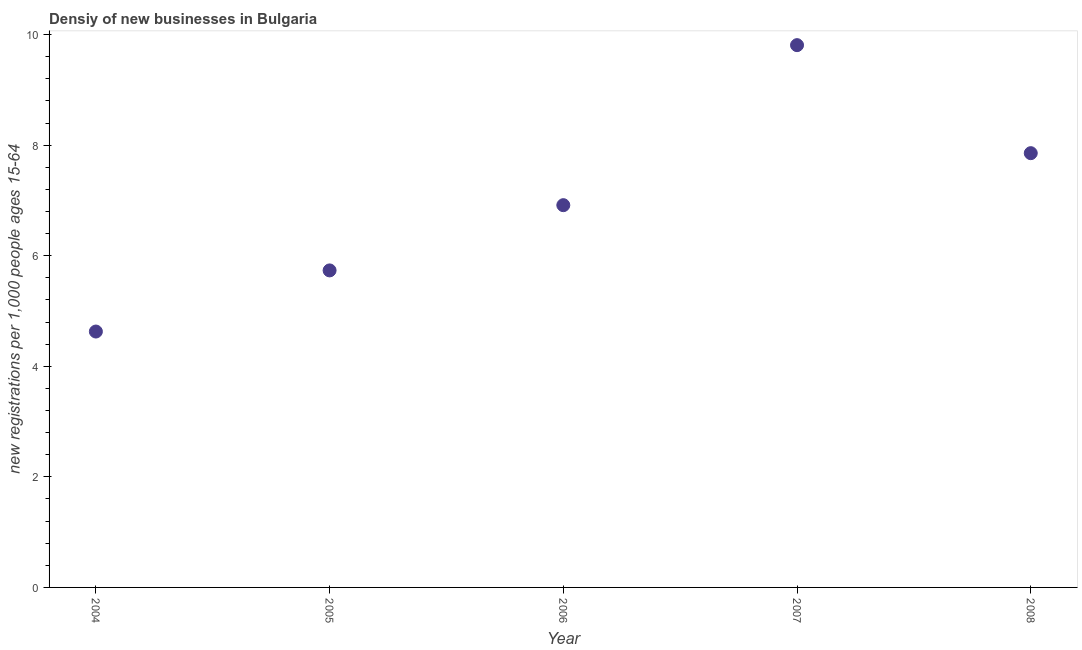What is the density of new business in 2004?
Your answer should be compact. 4.63. Across all years, what is the maximum density of new business?
Offer a terse response. 9.81. Across all years, what is the minimum density of new business?
Make the answer very short. 4.63. In which year was the density of new business minimum?
Offer a very short reply. 2004. What is the sum of the density of new business?
Your response must be concise. 34.94. What is the difference between the density of new business in 2005 and 2008?
Give a very brief answer. -2.12. What is the average density of new business per year?
Your response must be concise. 6.99. What is the median density of new business?
Your answer should be compact. 6.91. What is the ratio of the density of new business in 2004 to that in 2007?
Your answer should be compact. 0.47. Is the density of new business in 2005 less than that in 2007?
Provide a succinct answer. Yes. What is the difference between the highest and the second highest density of new business?
Offer a very short reply. 1.95. What is the difference between the highest and the lowest density of new business?
Your answer should be compact. 5.18. In how many years, is the density of new business greater than the average density of new business taken over all years?
Provide a short and direct response. 2. Does the density of new business monotonically increase over the years?
Your response must be concise. No. How many dotlines are there?
Your answer should be very brief. 1. What is the difference between two consecutive major ticks on the Y-axis?
Your answer should be compact. 2. Are the values on the major ticks of Y-axis written in scientific E-notation?
Ensure brevity in your answer.  No. Does the graph contain any zero values?
Offer a very short reply. No. What is the title of the graph?
Keep it short and to the point. Densiy of new businesses in Bulgaria. What is the label or title of the X-axis?
Give a very brief answer. Year. What is the label or title of the Y-axis?
Ensure brevity in your answer.  New registrations per 1,0 people ages 15-64. What is the new registrations per 1,000 people ages 15-64 in 2004?
Offer a very short reply. 4.63. What is the new registrations per 1,000 people ages 15-64 in 2005?
Make the answer very short. 5.73. What is the new registrations per 1,000 people ages 15-64 in 2006?
Your answer should be very brief. 6.91. What is the new registrations per 1,000 people ages 15-64 in 2007?
Give a very brief answer. 9.81. What is the new registrations per 1,000 people ages 15-64 in 2008?
Provide a short and direct response. 7.86. What is the difference between the new registrations per 1,000 people ages 15-64 in 2004 and 2005?
Your answer should be compact. -1.11. What is the difference between the new registrations per 1,000 people ages 15-64 in 2004 and 2006?
Your answer should be compact. -2.29. What is the difference between the new registrations per 1,000 people ages 15-64 in 2004 and 2007?
Your answer should be very brief. -5.18. What is the difference between the new registrations per 1,000 people ages 15-64 in 2004 and 2008?
Your response must be concise. -3.23. What is the difference between the new registrations per 1,000 people ages 15-64 in 2005 and 2006?
Your answer should be very brief. -1.18. What is the difference between the new registrations per 1,000 people ages 15-64 in 2005 and 2007?
Make the answer very short. -4.07. What is the difference between the new registrations per 1,000 people ages 15-64 in 2005 and 2008?
Make the answer very short. -2.12. What is the difference between the new registrations per 1,000 people ages 15-64 in 2006 and 2007?
Your answer should be compact. -2.89. What is the difference between the new registrations per 1,000 people ages 15-64 in 2006 and 2008?
Your answer should be very brief. -0.94. What is the difference between the new registrations per 1,000 people ages 15-64 in 2007 and 2008?
Your response must be concise. 1.95. What is the ratio of the new registrations per 1,000 people ages 15-64 in 2004 to that in 2005?
Your response must be concise. 0.81. What is the ratio of the new registrations per 1,000 people ages 15-64 in 2004 to that in 2006?
Your answer should be very brief. 0.67. What is the ratio of the new registrations per 1,000 people ages 15-64 in 2004 to that in 2007?
Offer a very short reply. 0.47. What is the ratio of the new registrations per 1,000 people ages 15-64 in 2004 to that in 2008?
Offer a terse response. 0.59. What is the ratio of the new registrations per 1,000 people ages 15-64 in 2005 to that in 2006?
Provide a succinct answer. 0.83. What is the ratio of the new registrations per 1,000 people ages 15-64 in 2005 to that in 2007?
Ensure brevity in your answer.  0.58. What is the ratio of the new registrations per 1,000 people ages 15-64 in 2005 to that in 2008?
Your answer should be very brief. 0.73. What is the ratio of the new registrations per 1,000 people ages 15-64 in 2006 to that in 2007?
Keep it short and to the point. 0.7. What is the ratio of the new registrations per 1,000 people ages 15-64 in 2007 to that in 2008?
Keep it short and to the point. 1.25. 